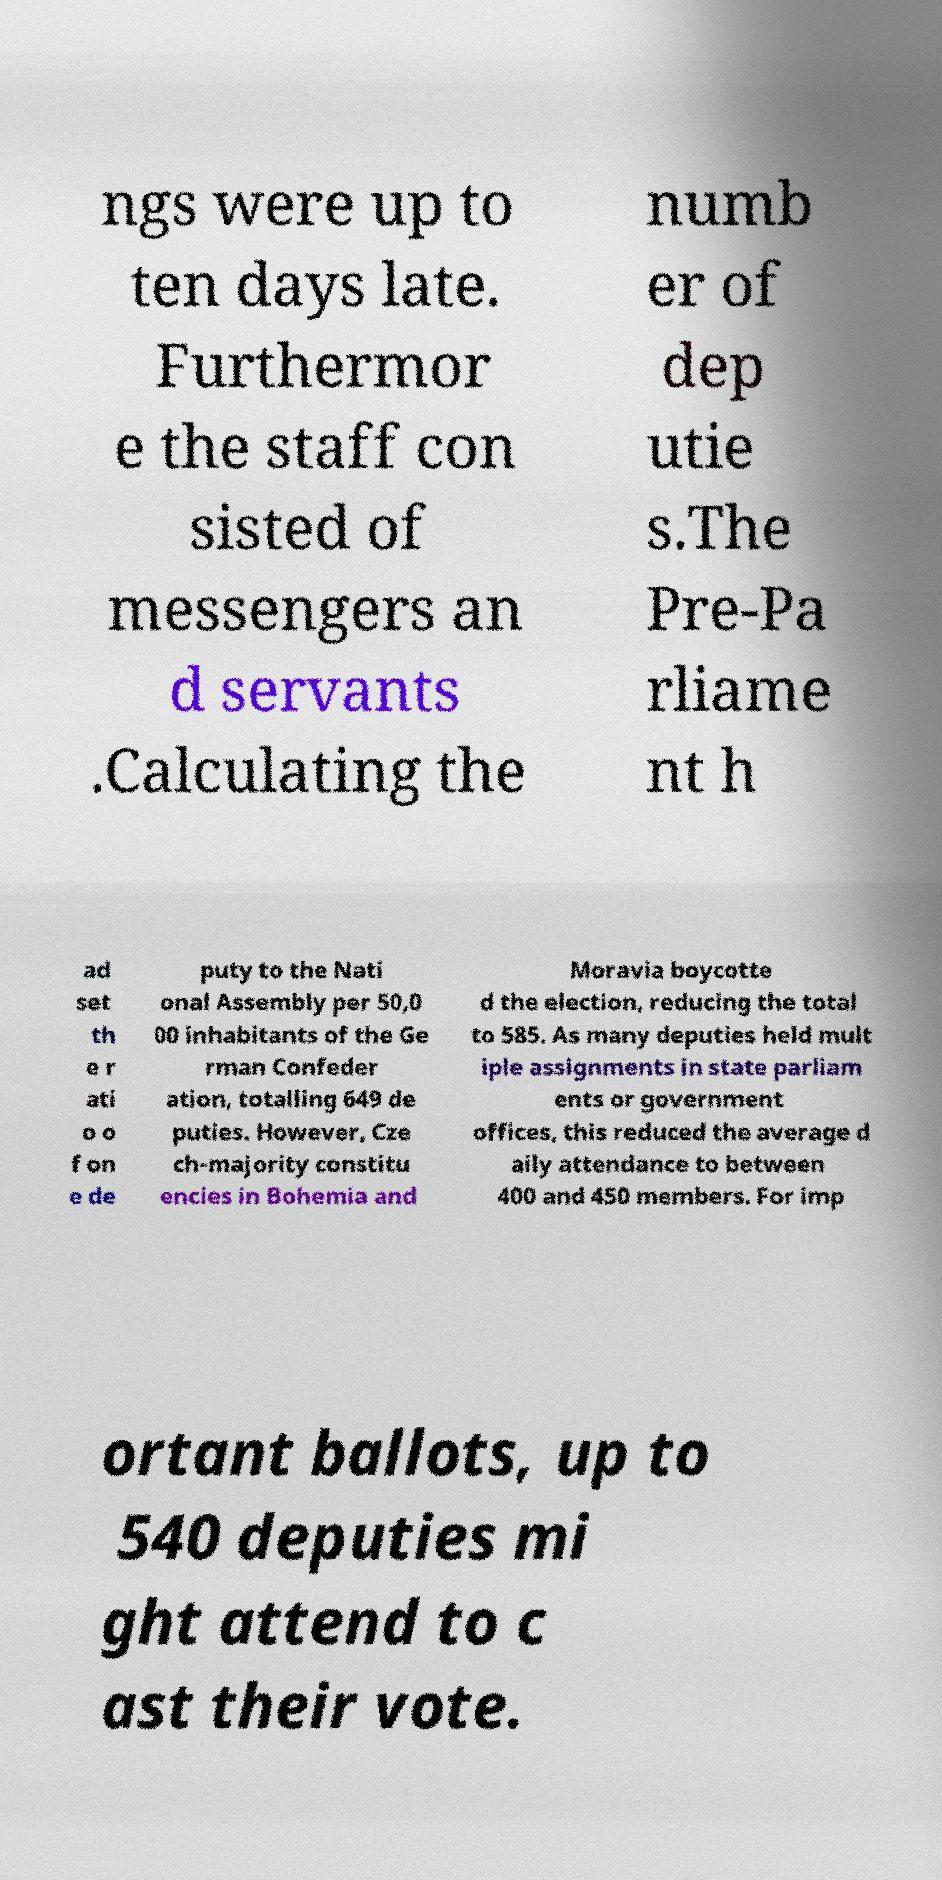Please identify and transcribe the text found in this image. ngs were up to ten days late. Furthermor e the staff con sisted of messengers an d servants .Calculating the numb er of dep utie s.The Pre-Pa rliame nt h ad set th e r ati o o f on e de puty to the Nati onal Assembly per 50,0 00 inhabitants of the Ge rman Confeder ation, totalling 649 de puties. However, Cze ch-majority constitu encies in Bohemia and Moravia boycotte d the election, reducing the total to 585. As many deputies held mult iple assignments in state parliam ents or government offices, this reduced the average d aily attendance to between 400 and 450 members. For imp ortant ballots, up to 540 deputies mi ght attend to c ast their vote. 